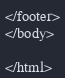<code> <loc_0><loc_0><loc_500><loc_500><_PHP_></footer>
</body>

</html></code> 